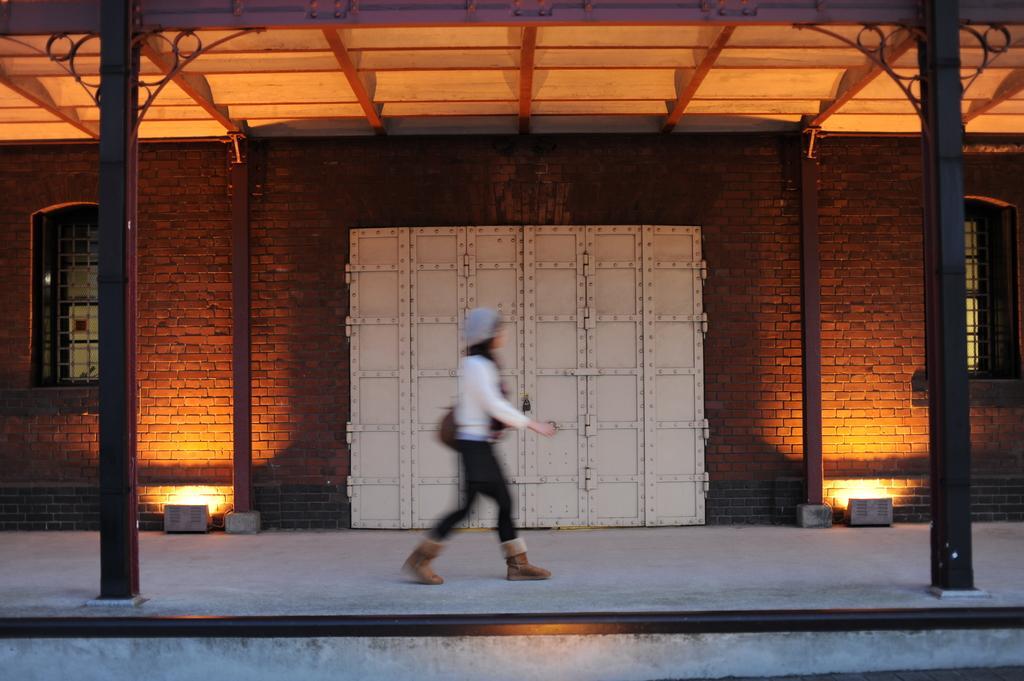Can you describe this image briefly? In the image we can see a woman walking, she is wearing white color shirt, boots and hat. In the background there is a wall. It is in red color and there are two window one on the right and other on the left. In the middle there is a metal door. 